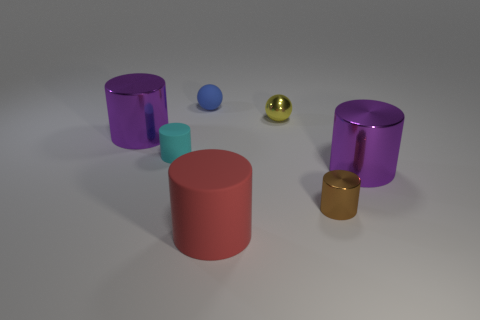Subtract all brown cylinders. How many cylinders are left? 4 Subtract all brown shiny cylinders. How many cylinders are left? 4 Subtract all blue cylinders. Subtract all red spheres. How many cylinders are left? 5 Add 3 gray balls. How many objects exist? 10 Subtract all cylinders. How many objects are left? 2 Add 7 green metallic cylinders. How many green metallic cylinders exist? 7 Subtract 0 gray cylinders. How many objects are left? 7 Subtract all big cyan cylinders. Subtract all brown metallic objects. How many objects are left? 6 Add 6 tiny metal cylinders. How many tiny metal cylinders are left? 7 